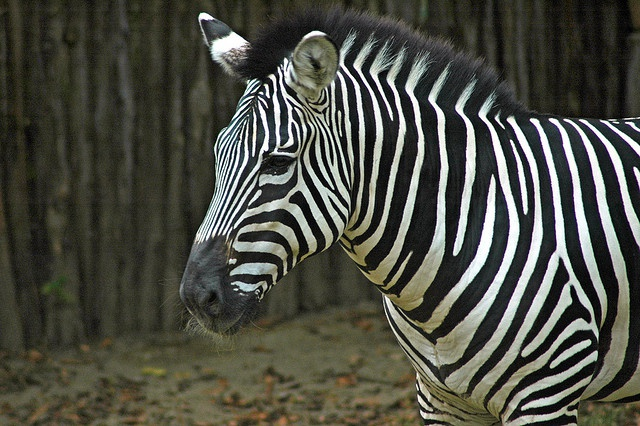Describe the objects in this image and their specific colors. I can see a zebra in black, white, gray, and darkgray tones in this image. 